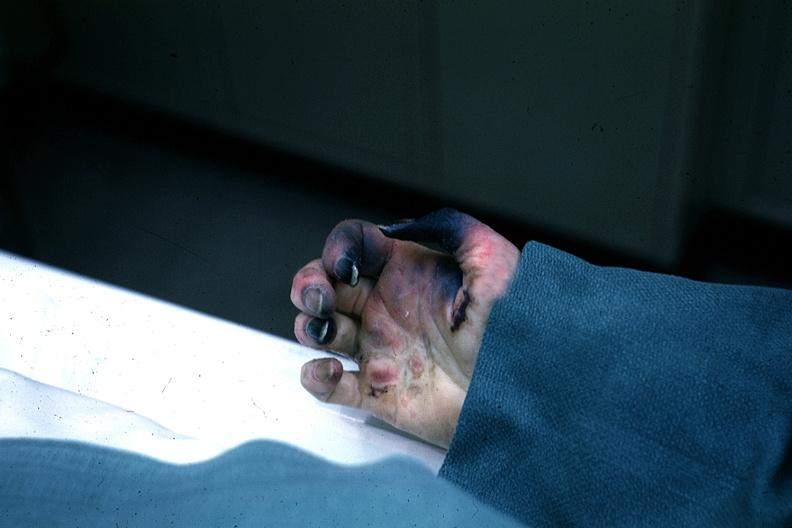what is excellent gangrenous necrosis of fingers said?
Answer the question using a single word or phrase. To be due to embolism 